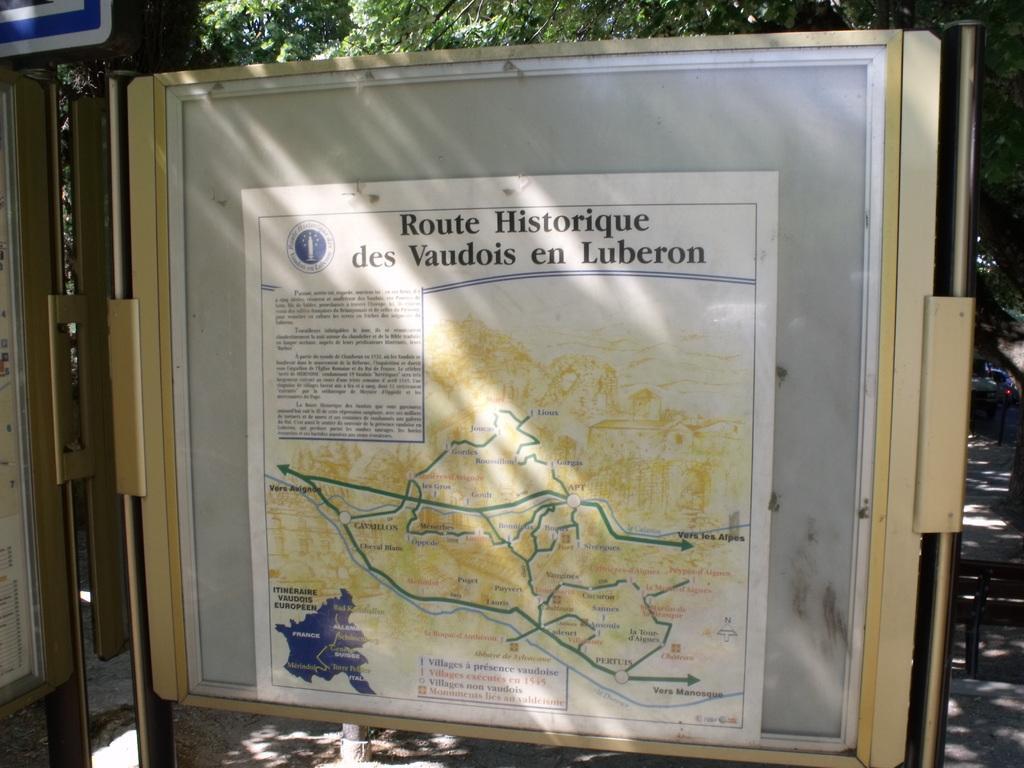Describe this image in one or two sentences. This image consists of a poster pasted on the board. At the bottom, there is road. In the background, there are trees. 